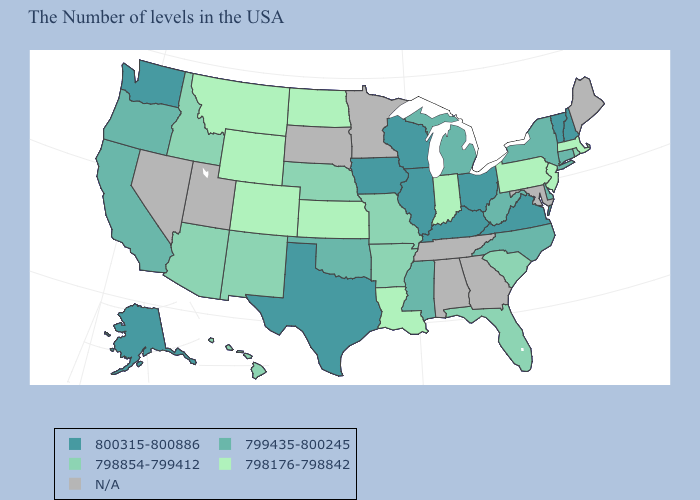Which states have the highest value in the USA?
Quick response, please. New Hampshire, Vermont, Virginia, Ohio, Kentucky, Wisconsin, Illinois, Iowa, Texas, Washington, Alaska. What is the highest value in the USA?
Keep it brief. 800315-800886. What is the lowest value in states that border Idaho?
Quick response, please. 798176-798842. Among the states that border New Jersey , which have the lowest value?
Concise answer only. Pennsylvania. Name the states that have a value in the range 800315-800886?
Keep it brief. New Hampshire, Vermont, Virginia, Ohio, Kentucky, Wisconsin, Illinois, Iowa, Texas, Washington, Alaska. What is the value of Iowa?
Keep it brief. 800315-800886. Which states hav the highest value in the Northeast?
Give a very brief answer. New Hampshire, Vermont. Which states have the highest value in the USA?
Short answer required. New Hampshire, Vermont, Virginia, Ohio, Kentucky, Wisconsin, Illinois, Iowa, Texas, Washington, Alaska. What is the lowest value in states that border Kansas?
Concise answer only. 798176-798842. Name the states that have a value in the range 800315-800886?
Give a very brief answer. New Hampshire, Vermont, Virginia, Ohio, Kentucky, Wisconsin, Illinois, Iowa, Texas, Washington, Alaska. How many symbols are there in the legend?
Be succinct. 5. What is the lowest value in the USA?
Keep it brief. 798176-798842. 